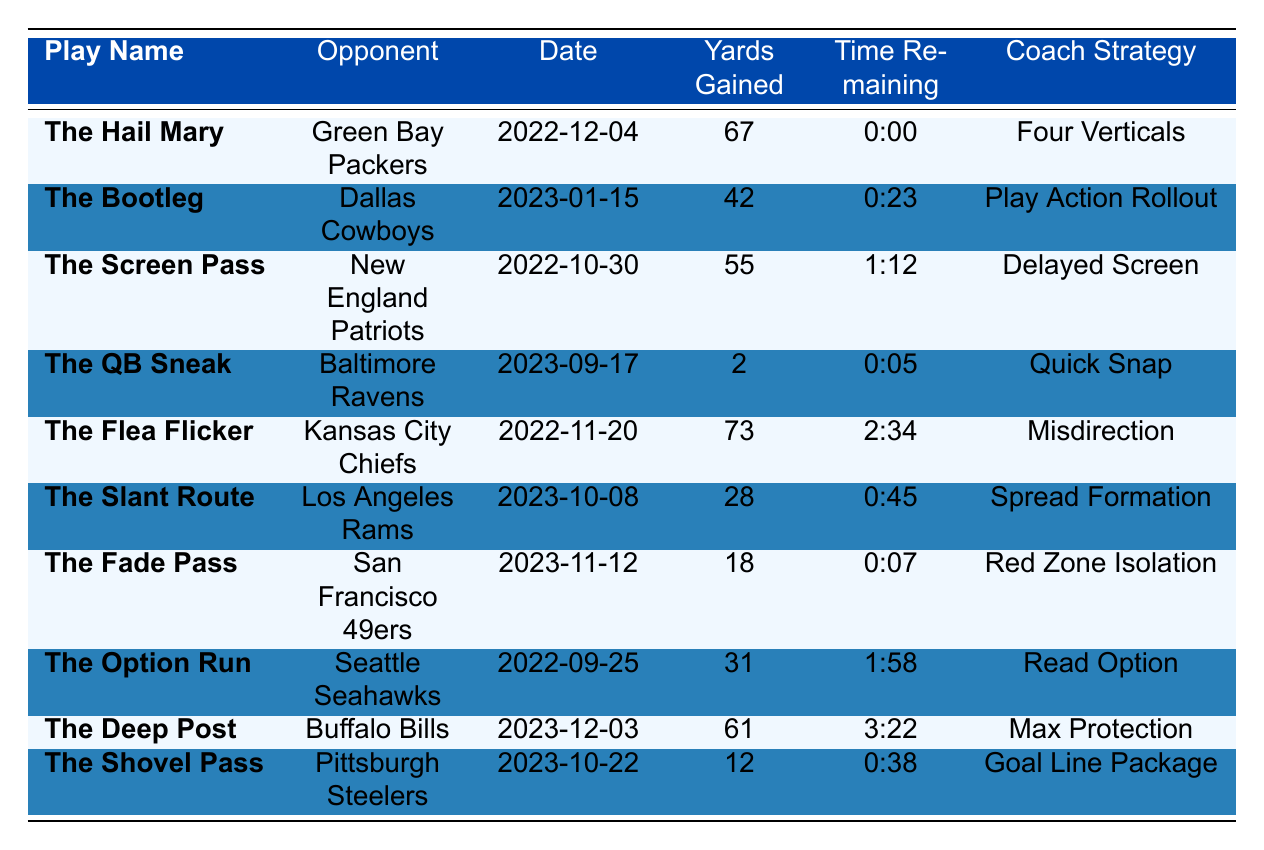What was the longest yardage gained on a play? The table shows the yardage gained for each play. The longest yardage is 73 yards, which was achieved on "The Flea Flicker" against the Kansas City Chiefs.
Answer: 73 yards Which play was executed with the least amount of yards gained? By checking the yards gained for each play listed in the table, "The QB Sneak" gained only 2 yards, making it the play with the least yardage.
Answer: 2 yards Were there any plays that gained 50 yards or more? Looking through the yards gained, "The Hail Mary," "The Screen Pass," "The Flea Flicker," and "The Deep Post" all gained over 50 yards, confirming that there were multiple such plays.
Answer: Yes What percentage of the game-winning plays used a strategy involving misdirection? Two plays used the "Misdirection" strategy out of ten total plays. Therefore, the percentage is (2/10) * 100 = 20%.
Answer: 20% Which opponent's defense did the quarterback perform a play resulting in a touchdown with the most yardage and what strategy was used? "The Flea Flicker" against the Kansas City Chiefs gained 73 yards, the highest in the table, and used the "Misdirection" strategy.
Answer: Kansas City Chiefs, Misdirection What play had the least amount of time remaining on the clock when executed? The play with the least time remaining is "The Fade Pass" with only 0:07 on the clock at the moment it was executed against the San Francisco 49ers.
Answer: The Fade Pass On what date was "The Bootleg" executed, and how many yards did it gain? According to the table, "The Bootleg" was executed on January 15, 2023, and it gained 42 yards.
Answer: January 15, 2023, 42 yards Which coach strategy was involved in plays gaining a total of more than 120 yards? "The Hail Mary" (67 yards) and "The Deep Post" (61 yards) both used the "Max Protection" strategy, totaling 128 yards, which is more than 120 yards.
Answer: Max Protection How many plays were executed with less than 30 yards gained? Reviewing the table, "The Fade Pass" (18 yards), "The QB Sneak" (2 yards), and "The Shovel Pass" (12 yards) all gained less than 30 yards, accounting for three plays in total.
Answer: 3 plays Were there any plays that resulted in gaining exactly 30 yards? A review of the yardage data shows that no play in the table has an exact yardage of 30 yards.
Answer: No 